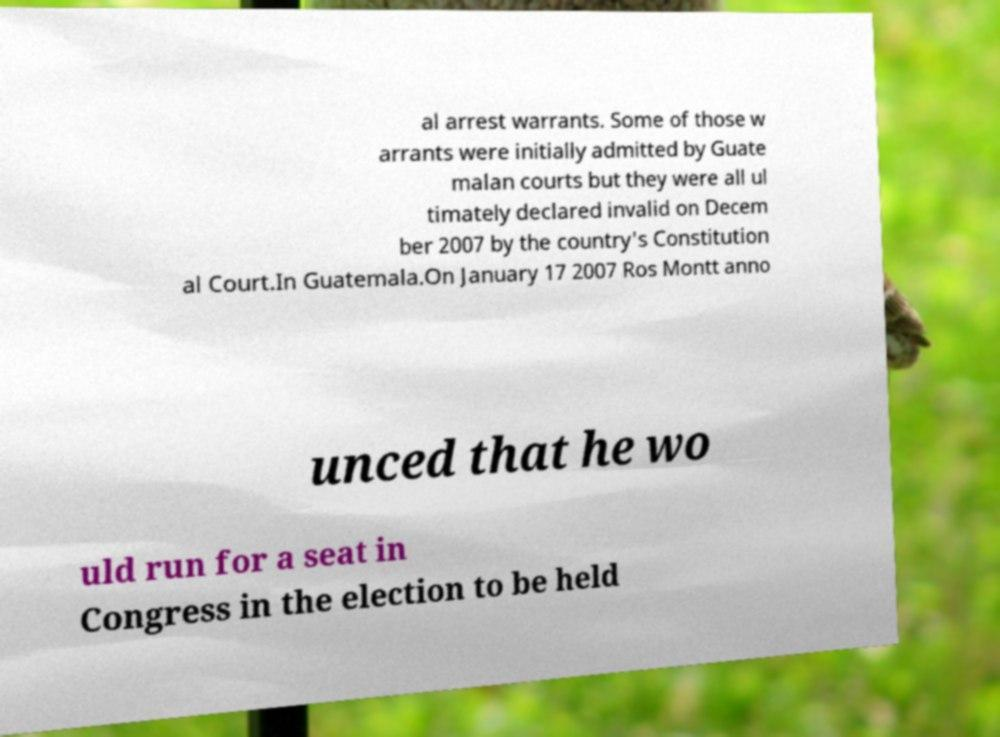For documentation purposes, I need the text within this image transcribed. Could you provide that? al arrest warrants. Some of those w arrants were initially admitted by Guate malan courts but they were all ul timately declared invalid on Decem ber 2007 by the country's Constitution al Court.In Guatemala.On January 17 2007 Ros Montt anno unced that he wo uld run for a seat in Congress in the election to be held 